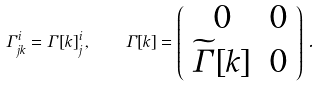Convert formula to latex. <formula><loc_0><loc_0><loc_500><loc_500>\Gamma ^ { i } _ { j k } = \Gamma [ k ] ^ { i } _ { j } \, , \quad \Gamma [ k ] = \left ( \begin{array} { c c } 0 & 0 \\ \widetilde { \Gamma } [ k ] & 0 \end{array} \right ) \, .</formula> 